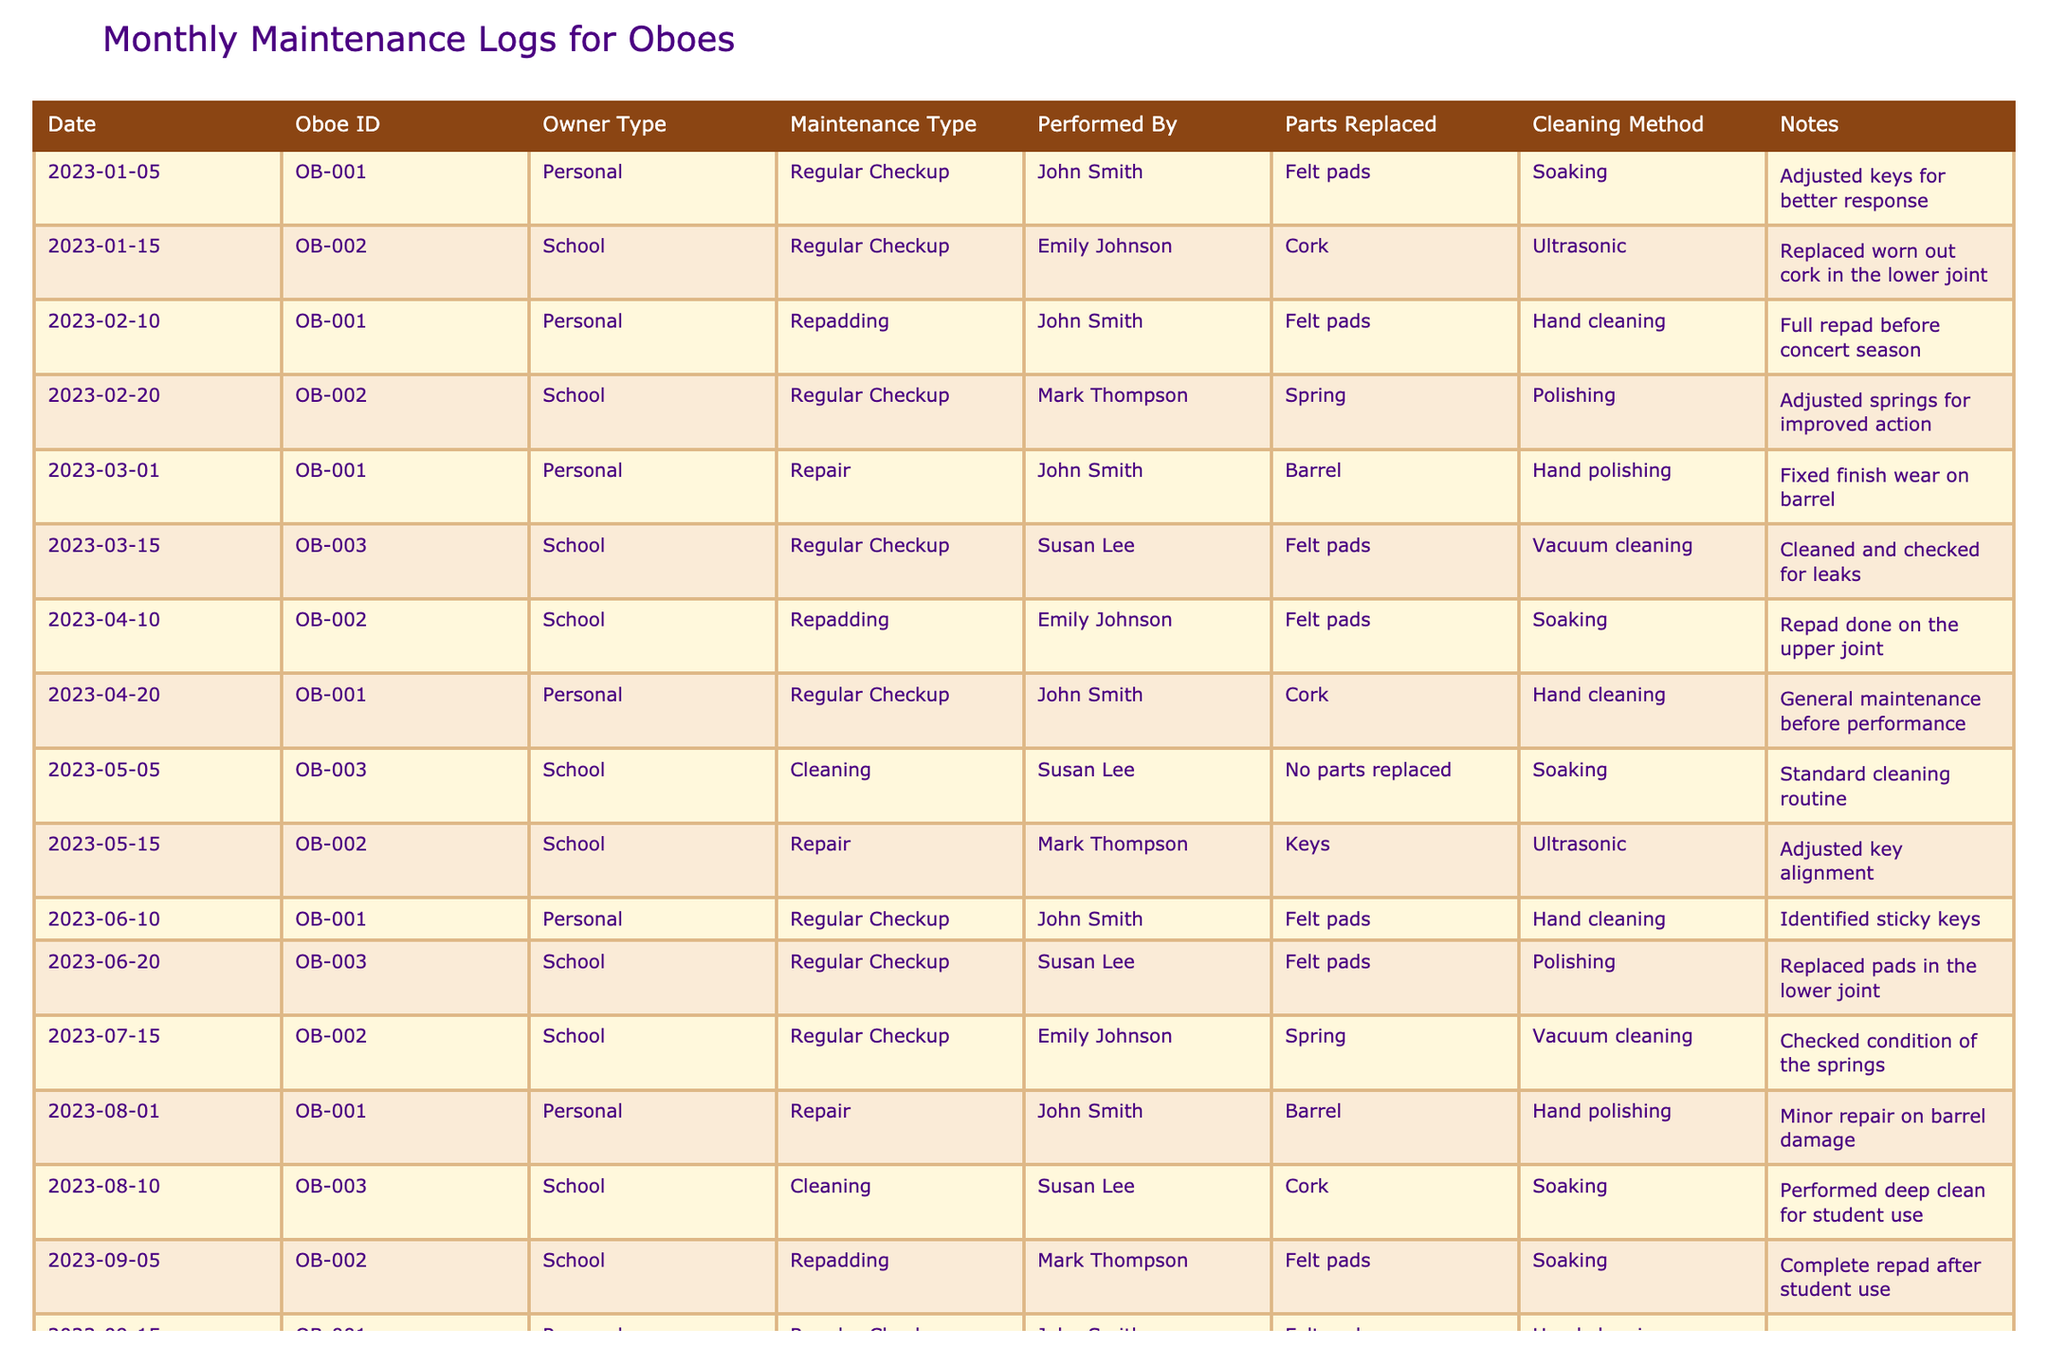What is the maintenance type performed on Oboe ID OB-001 on February 10, 2023? The table shows that on February 10, 2023, Oboe ID OB-001 had a "Repadding" maintenance type performed.
Answer: Repadding Who performed the regular checkup on Oboe ID OB-002 on January 15, 2023? According to the table, the regular checkup on Oboe ID OB-002 was performed by Emily Johnson.
Answer: Emily Johnson How many regular checkups were performed on Oboe ID OB-003 in 2023? The table indicates that there were three entries for "Regular Checkup" for Oboe ID OB-003 in 2023 (March 15, June 20, and October 3).
Answer: Three What parts were replaced on Oboe ID OB-002 during its maintenance on September 5, 2023? Looking at the table for the date September 5, 2023, Oboe ID OB-002 had "Felt pads" replaced during maintenance.
Answer: Felt pads Was a cleaning method utilized for the maintenance of Oboe ID OB-003 on May 5, 2023? Yes, the maintenance on May 5, 2023, for Oboe ID OB-003 used the "Soaking" cleaning method, as noted in the table.
Answer: Yes How many instances of repadding were recorded across all oboes? By analyzing the table, there were four instances of "Repadding" noted for Oboes OB-001, OB-002, and OB-003 throughout the entries.
Answer: Four Which oboe had its keys adjusted during maintenance on May 15, 2023? The table indicates that on May 15, 2023, the keys of Oboe ID OB-002 were adjusted during the maintenance performed by Mark Thompson.
Answer: Oboe ID OB-002 What is the most common maintenance type performed on personal oboes? By reviewing the table, the most common maintenance type for personal oboes (OB-001) is "Regular Checkup," which appears multiple times compared to other types.
Answer: Regular Checkup How many months had repairs performed on Oboe ID OB-001 by the end of 2023? Checking the entries for Oboe ID OB-001, repairs were performed in March, August, and November of 2023, accounting for three months.
Answer: Three months Did any oboes have their pads replaced during maintenance in 2023? Yes, the table confirms that pads were replaced for Oboe ID OB-003 during maintenance on June 20 and November 20, 2023.
Answer: Yes What observations were made during the regular checkup of Oboe ID OB-001 on September 15, 2023? The table notes that during the regular checkup on September 15, 2023, the observer reported improved tonal quality for Oboe ID OB-001.
Answer: Improved tonal quality observed For which oboe was a deep clean performed on August 10, 2023? The table states that a deep clean was done on Oboe ID OB-003 on August 10, 2023.
Answer: Oboe ID OB-003 